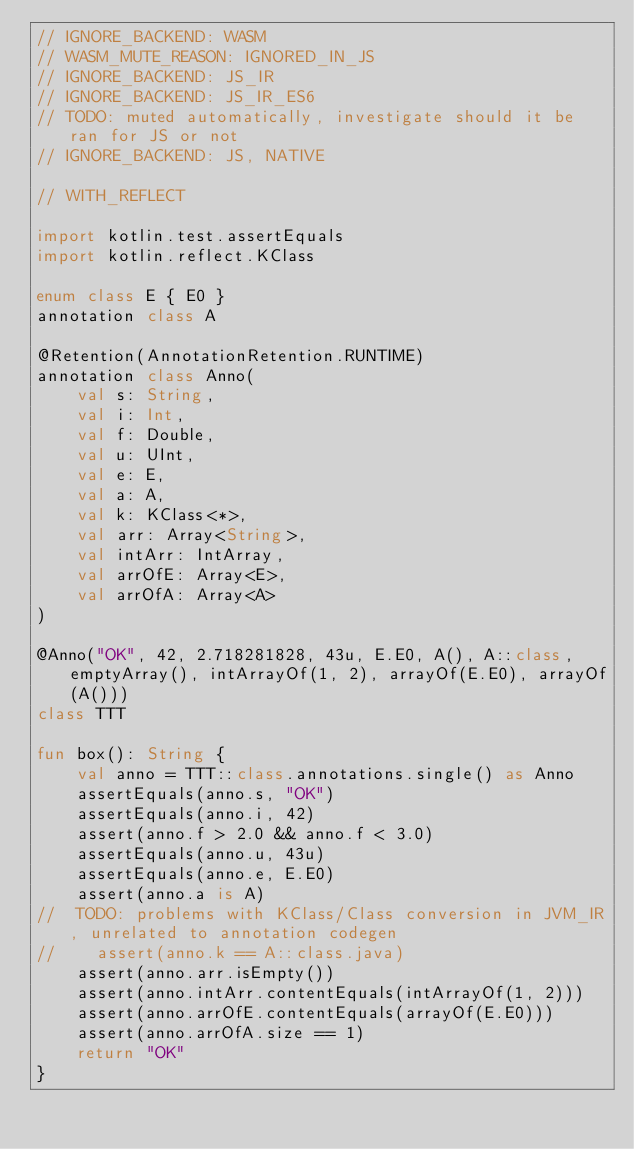Convert code to text. <code><loc_0><loc_0><loc_500><loc_500><_Kotlin_>// IGNORE_BACKEND: WASM
// WASM_MUTE_REASON: IGNORED_IN_JS
// IGNORE_BACKEND: JS_IR
// IGNORE_BACKEND: JS_IR_ES6
// TODO: muted automatically, investigate should it be ran for JS or not
// IGNORE_BACKEND: JS, NATIVE

// WITH_REFLECT

import kotlin.test.assertEquals
import kotlin.reflect.KClass

enum class E { E0 }
annotation class A

@Retention(AnnotationRetention.RUNTIME)
annotation class Anno(
    val s: String,
    val i: Int,
    val f: Double,
    val u: UInt,
    val e: E,
    val a: A,
    val k: KClass<*>,
    val arr: Array<String>,
    val intArr: IntArray,
    val arrOfE: Array<E>,
    val arrOfA: Array<A>
)

@Anno("OK", 42, 2.718281828, 43u, E.E0, A(), A::class, emptyArray(), intArrayOf(1, 2), arrayOf(E.E0), arrayOf(A()))
class TTT

fun box(): String {
    val anno = TTT::class.annotations.single() as Anno
    assertEquals(anno.s, "OK")
    assertEquals(anno.i, 42)
    assert(anno.f > 2.0 && anno.f < 3.0)
    assertEquals(anno.u, 43u)
    assertEquals(anno.e, E.E0)
    assert(anno.a is A)
//  TODO: problems with KClass/Class conversion in JVM_IR, unrelated to annotation codegen
//    assert(anno.k == A::class.java)
    assert(anno.arr.isEmpty())
    assert(anno.intArr.contentEquals(intArrayOf(1, 2)))
    assert(anno.arrOfE.contentEquals(arrayOf(E.E0)))
    assert(anno.arrOfA.size == 1)
    return "OK"
}
</code> 